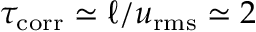<formula> <loc_0><loc_0><loc_500><loc_500>\tau _ { c o r r } \simeq \ell / u _ { r m s } \simeq 2</formula> 